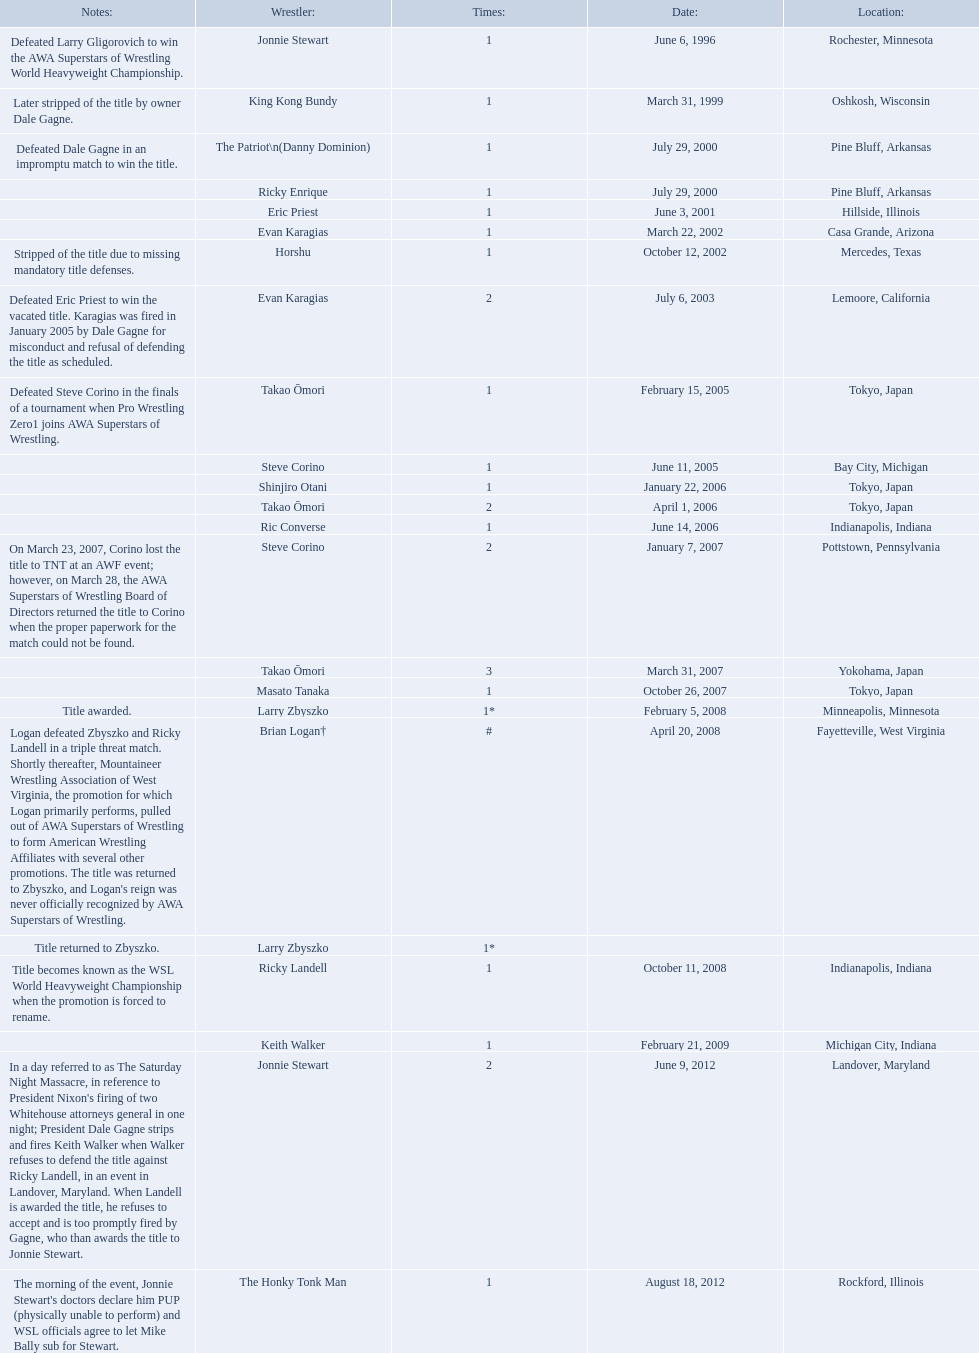Who are the wrestlers? Jonnie Stewart, Rochester, Minnesota, King Kong Bundy, Oshkosh, Wisconsin, The Patriot\n(Danny Dominion), Pine Bluff, Arkansas, Ricky Enrique, Pine Bluff, Arkansas, Eric Priest, Hillside, Illinois, Evan Karagias, Casa Grande, Arizona, Horshu, Mercedes, Texas, Evan Karagias, Lemoore, California, Takao Ōmori, Tokyo, Japan, Steve Corino, Bay City, Michigan, Shinjiro Otani, Tokyo, Japan, Takao Ōmori, Tokyo, Japan, Ric Converse, Indianapolis, Indiana, Steve Corino, Pottstown, Pennsylvania, Takao Ōmori, Yokohama, Japan, Masato Tanaka, Tokyo, Japan, Larry Zbyszko, Minneapolis, Minnesota, Brian Logan†, Fayetteville, West Virginia, Larry Zbyszko, , Ricky Landell, Indianapolis, Indiana, Keith Walker, Michigan City, Indiana, Jonnie Stewart, Landover, Maryland, The Honky Tonk Man, Rockford, Illinois. Who was from texas? Horshu, Mercedes, Texas. Who is he? Horshu. 